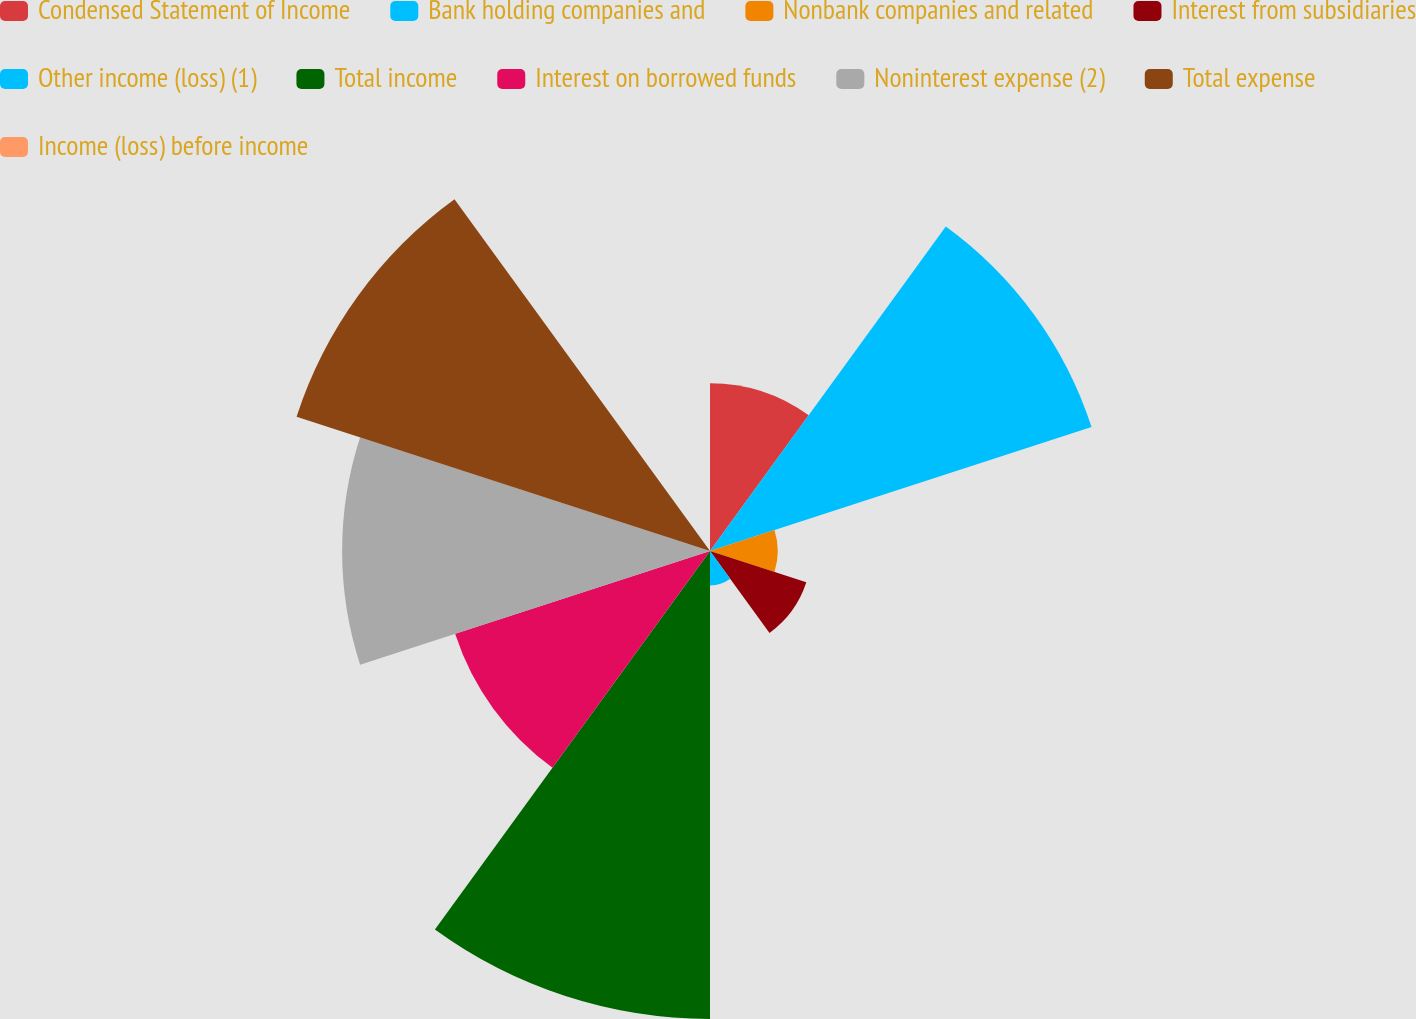Convert chart. <chart><loc_0><loc_0><loc_500><loc_500><pie_chart><fcel>Condensed Statement of Income<fcel>Bank holding companies and<fcel>Nonbank companies and related<fcel>Interest from subsidiaries<fcel>Other income (loss) (1)<fcel>Total income<fcel>Interest on borrowed funds<fcel>Noninterest expense (2)<fcel>Total expense<fcel>Income (loss) before income<nl><fcel>7.26%<fcel>17.35%<fcel>2.93%<fcel>4.38%<fcel>1.49%<fcel>20.24%<fcel>11.59%<fcel>15.91%<fcel>18.8%<fcel>0.05%<nl></chart> 